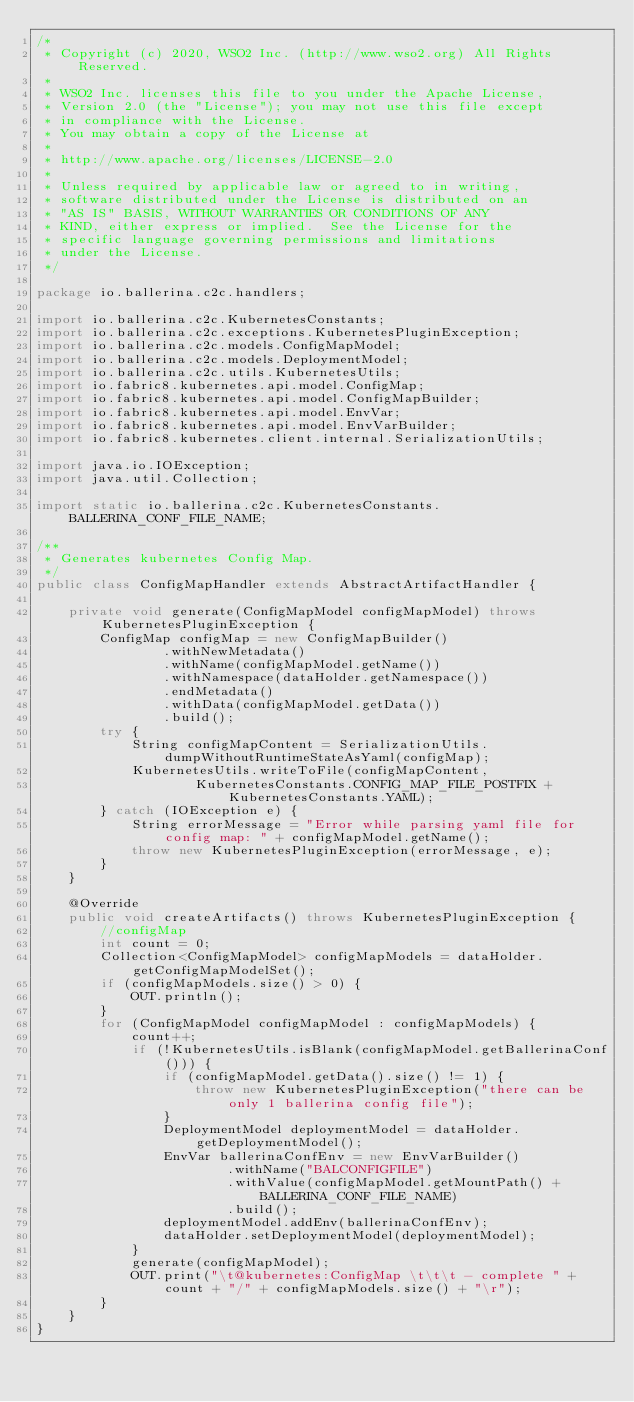Convert code to text. <code><loc_0><loc_0><loc_500><loc_500><_Java_>/*
 * Copyright (c) 2020, WSO2 Inc. (http://www.wso2.org) All Rights Reserved.
 *
 * WSO2 Inc. licenses this file to you under the Apache License,
 * Version 2.0 (the "License"); you may not use this file except
 * in compliance with the License.
 * You may obtain a copy of the License at
 *
 * http://www.apache.org/licenses/LICENSE-2.0
 *
 * Unless required by applicable law or agreed to in writing,
 * software distributed under the License is distributed on an
 * "AS IS" BASIS, WITHOUT WARRANTIES OR CONDITIONS OF ANY
 * KIND, either express or implied.  See the License for the
 * specific language governing permissions and limitations
 * under the License.
 */

package io.ballerina.c2c.handlers;

import io.ballerina.c2c.KubernetesConstants;
import io.ballerina.c2c.exceptions.KubernetesPluginException;
import io.ballerina.c2c.models.ConfigMapModel;
import io.ballerina.c2c.models.DeploymentModel;
import io.ballerina.c2c.utils.KubernetesUtils;
import io.fabric8.kubernetes.api.model.ConfigMap;
import io.fabric8.kubernetes.api.model.ConfigMapBuilder;
import io.fabric8.kubernetes.api.model.EnvVar;
import io.fabric8.kubernetes.api.model.EnvVarBuilder;
import io.fabric8.kubernetes.client.internal.SerializationUtils;

import java.io.IOException;
import java.util.Collection;

import static io.ballerina.c2c.KubernetesConstants.BALLERINA_CONF_FILE_NAME;

/**
 * Generates kubernetes Config Map.
 */
public class ConfigMapHandler extends AbstractArtifactHandler {

    private void generate(ConfigMapModel configMapModel) throws KubernetesPluginException {
        ConfigMap configMap = new ConfigMapBuilder()
                .withNewMetadata()
                .withName(configMapModel.getName())
                .withNamespace(dataHolder.getNamespace())
                .endMetadata()
                .withData(configMapModel.getData())
                .build();
        try {
            String configMapContent = SerializationUtils.dumpWithoutRuntimeStateAsYaml(configMap);
            KubernetesUtils.writeToFile(configMapContent,
                    KubernetesConstants.CONFIG_MAP_FILE_POSTFIX + KubernetesConstants.YAML);
        } catch (IOException e) {
            String errorMessage = "Error while parsing yaml file for config map: " + configMapModel.getName();
            throw new KubernetesPluginException(errorMessage, e);
        }
    }

    @Override
    public void createArtifacts() throws KubernetesPluginException {
        //configMap
        int count = 0;
        Collection<ConfigMapModel> configMapModels = dataHolder.getConfigMapModelSet();
        if (configMapModels.size() > 0) {
            OUT.println();
        }
        for (ConfigMapModel configMapModel : configMapModels) {
            count++;
            if (!KubernetesUtils.isBlank(configMapModel.getBallerinaConf())) {
                if (configMapModel.getData().size() != 1) {
                    throw new KubernetesPluginException("there can be only 1 ballerina config file");
                }
                DeploymentModel deploymentModel = dataHolder.getDeploymentModel();
                EnvVar ballerinaConfEnv = new EnvVarBuilder()
                        .withName("BALCONFIGFILE")
                        .withValue(configMapModel.getMountPath() + BALLERINA_CONF_FILE_NAME)
                        .build();
                deploymentModel.addEnv(ballerinaConfEnv);
                dataHolder.setDeploymentModel(deploymentModel);
            }
            generate(configMapModel);
            OUT.print("\t@kubernetes:ConfigMap \t\t\t - complete " + count + "/" + configMapModels.size() + "\r");
        }
    }
}
</code> 